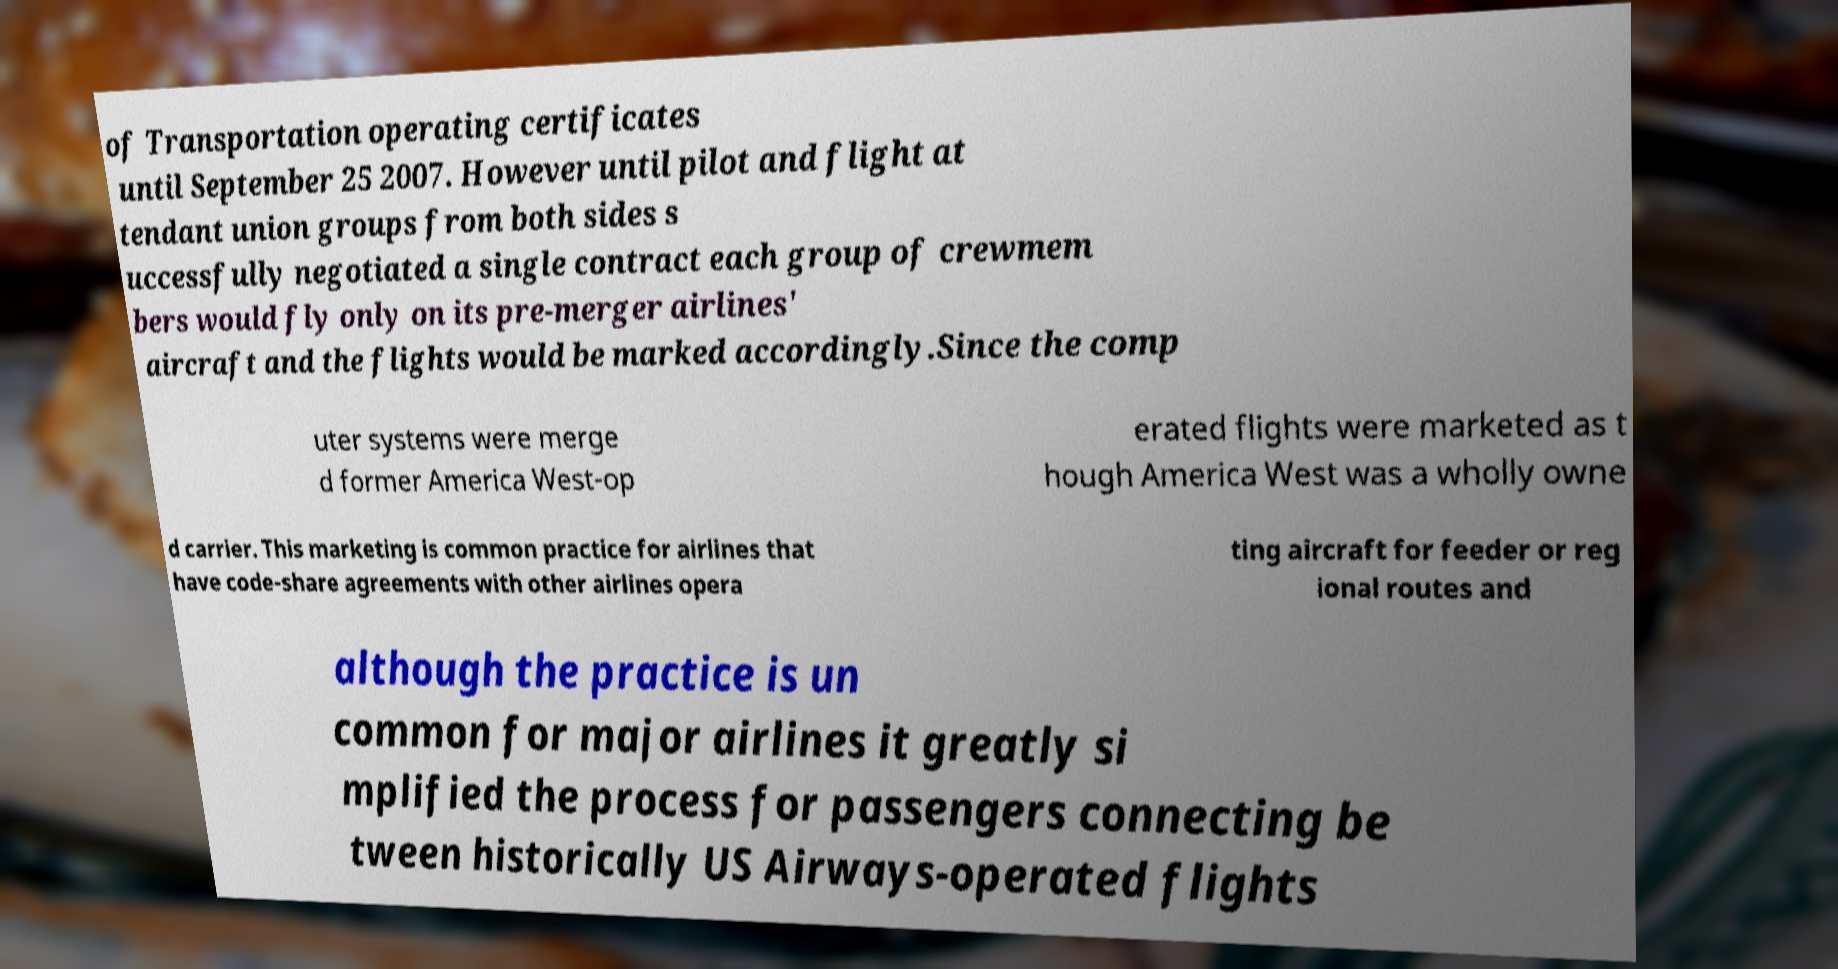Please identify and transcribe the text found in this image. of Transportation operating certificates until September 25 2007. However until pilot and flight at tendant union groups from both sides s uccessfully negotiated a single contract each group of crewmem bers would fly only on its pre-merger airlines' aircraft and the flights would be marked accordingly.Since the comp uter systems were merge d former America West-op erated flights were marketed as t hough America West was a wholly owne d carrier. This marketing is common practice for airlines that have code-share agreements with other airlines opera ting aircraft for feeder or reg ional routes and although the practice is un common for major airlines it greatly si mplified the process for passengers connecting be tween historically US Airways-operated flights 